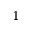Convert formula to latex. <formula><loc_0><loc_0><loc_500><loc_500>^ { 1 }</formula> 